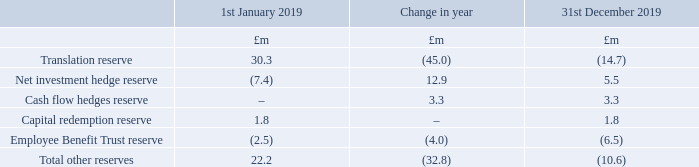21 Called up share capital and reserves
Other reserves in the Consolidated Statement of Changes in Equity on pages 151 to 152 are made up as follows:
The change in translation reserve includes a £1.4m credit transferred from retained earnings.
What is the  Translation reserve at the beginning of 2019?
Answer scale should be: million. 30.3. What does the change in translation reserve include? A £1.4m credit transferred from retained earnings. What are the types of Other reserves? Translation reserve, net investment hedge reserve, cash flow hedges reserve, capital redemption reserve, employee benefit trust reserve. How many types of other reserves registered a negative Change in year amount? Translation reserve##Employee Benefit Trust reserve
Answer: 2. What was the amount of capital redemption reserve as a percentage of the total other reserves on 1st January 2019?
Answer scale should be: percent. 1.8/22.2
Answer: 8.11. What was the percentage change in the amount of  Translation reserve  from 1st January 2019 to 31st December 2019?
Answer scale should be: percent. (-14.7-30.3)/30.3
Answer: -148.51. 